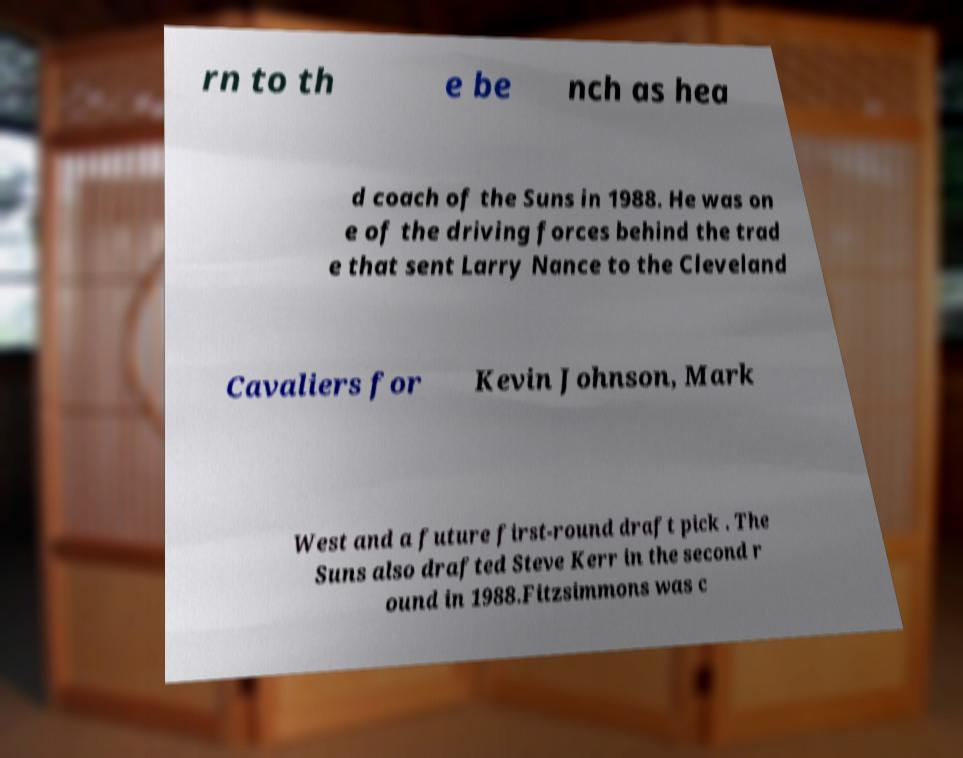I need the written content from this picture converted into text. Can you do that? rn to th e be nch as hea d coach of the Suns in 1988. He was on e of the driving forces behind the trad e that sent Larry Nance to the Cleveland Cavaliers for Kevin Johnson, Mark West and a future first-round draft pick . The Suns also drafted Steve Kerr in the second r ound in 1988.Fitzsimmons was c 